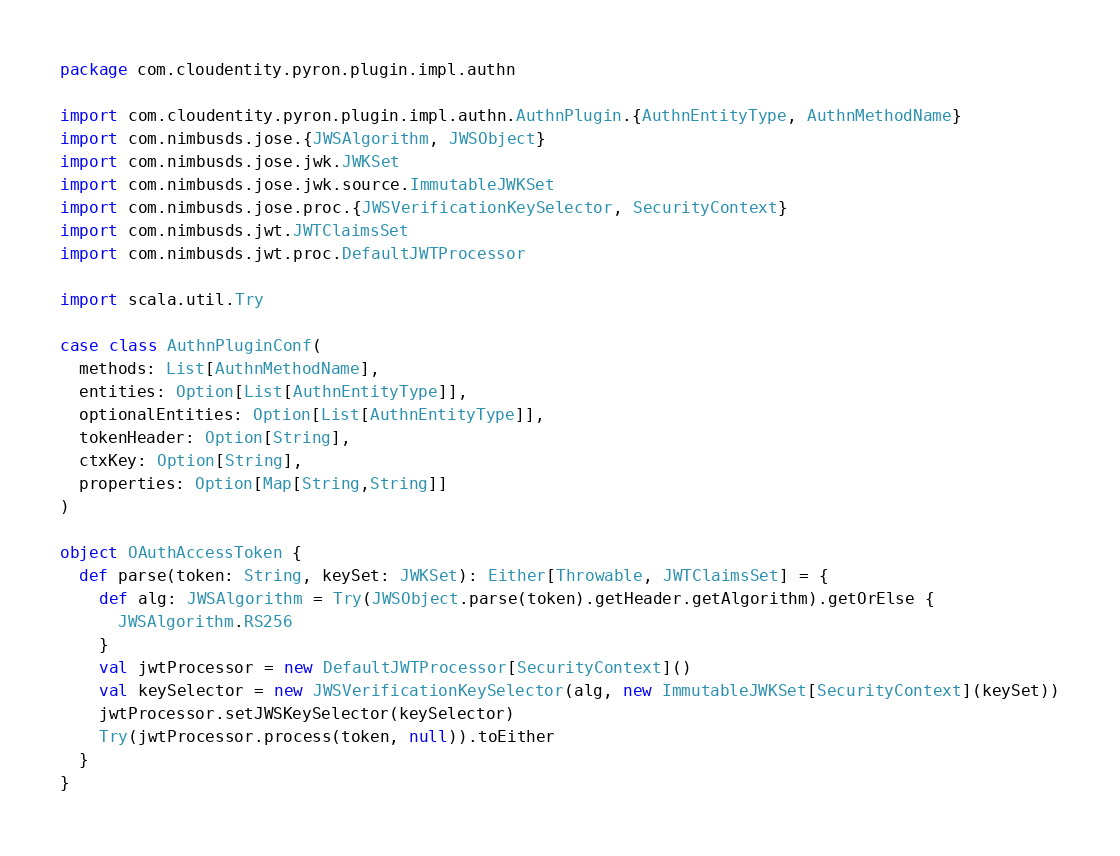<code> <loc_0><loc_0><loc_500><loc_500><_Scala_>package com.cloudentity.pyron.plugin.impl.authn

import com.cloudentity.pyron.plugin.impl.authn.AuthnPlugin.{AuthnEntityType, AuthnMethodName}
import com.nimbusds.jose.{JWSAlgorithm, JWSObject}
import com.nimbusds.jose.jwk.JWKSet
import com.nimbusds.jose.jwk.source.ImmutableJWKSet
import com.nimbusds.jose.proc.{JWSVerificationKeySelector, SecurityContext}
import com.nimbusds.jwt.JWTClaimsSet
import com.nimbusds.jwt.proc.DefaultJWTProcessor

import scala.util.Try

case class AuthnPluginConf(
  methods: List[AuthnMethodName],
  entities: Option[List[AuthnEntityType]],
  optionalEntities: Option[List[AuthnEntityType]],
  tokenHeader: Option[String],
  ctxKey: Option[String],
  properties: Option[Map[String,String]]
)

object OAuthAccessToken {
  def parse(token: String, keySet: JWKSet): Either[Throwable, JWTClaimsSet] = {
    def alg: JWSAlgorithm = Try(JWSObject.parse(token).getHeader.getAlgorithm).getOrElse {
      JWSAlgorithm.RS256
    }
    val jwtProcessor = new DefaultJWTProcessor[SecurityContext]()
    val keySelector = new JWSVerificationKeySelector(alg, new ImmutableJWKSet[SecurityContext](keySet))
    jwtProcessor.setJWSKeySelector(keySelector)
    Try(jwtProcessor.process(token, null)).toEither
  }
}</code> 